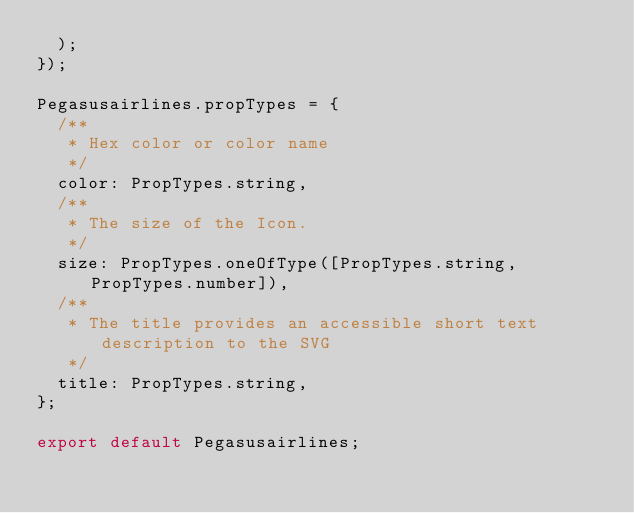<code> <loc_0><loc_0><loc_500><loc_500><_JavaScript_>  );
});

Pegasusairlines.propTypes = {
  /**
   * Hex color or color name
   */
  color: PropTypes.string,
  /**
   * The size of the Icon.
   */
  size: PropTypes.oneOfType([PropTypes.string, PropTypes.number]),
  /**
   * The title provides an accessible short text description to the SVG
   */
  title: PropTypes.string,
};

export default Pegasusairlines;
</code> 